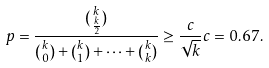Convert formula to latex. <formula><loc_0><loc_0><loc_500><loc_500>p = \frac { \binom { k } { \frac { k } { 2 } } } { \binom { k } { 0 } + \binom { k } { 1 } + \dots + \binom { k } { k } } \geq \frac { c } { \sqrt { k } } c = 0 . 6 7 .</formula> 